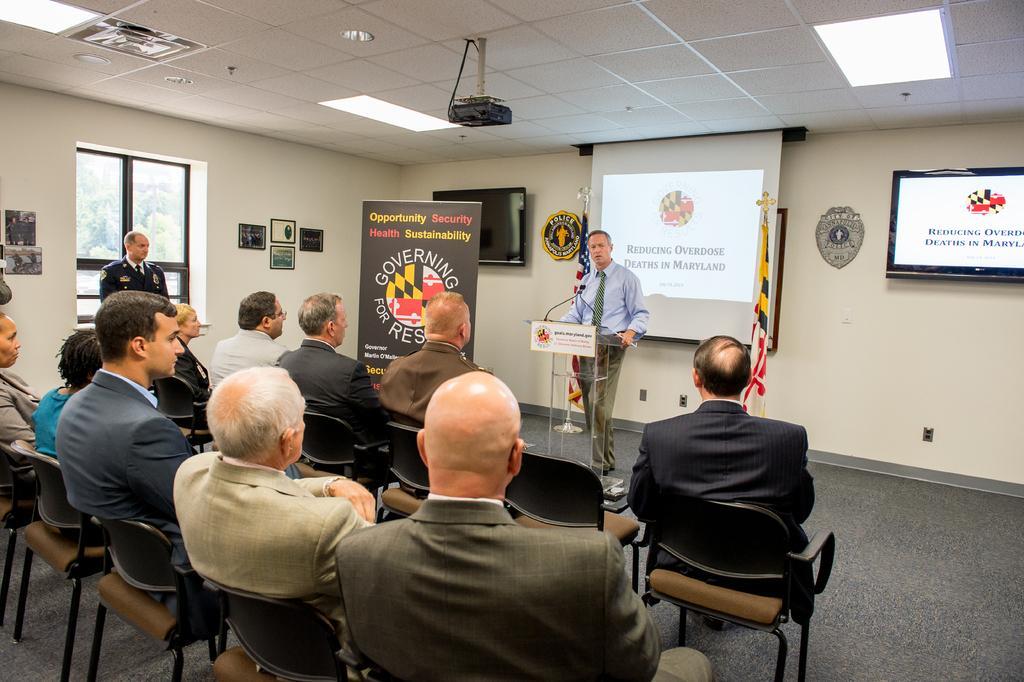How would you summarize this image in a sentence or two? In this picture there is man standing in front of podium and talking to the persons who are sitting in front of him. It looks like a meeting. At the back ground there is a projector and a television beside it. There is a banner beside the man who is standing. At the top there is ceiling and lights in between them. To the left side there is window. 